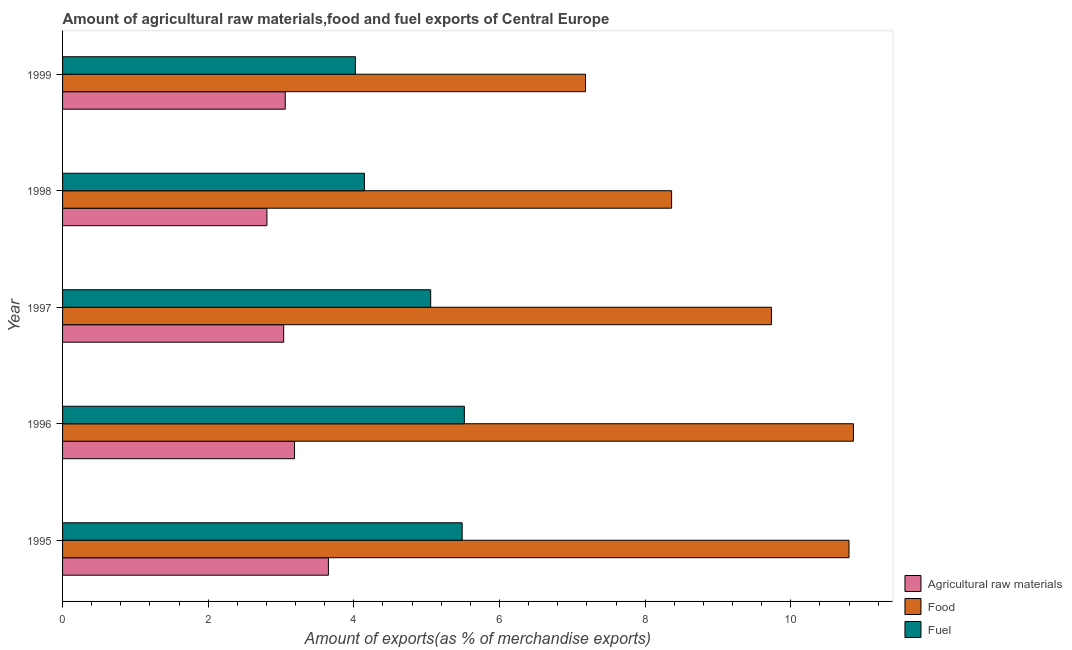How many groups of bars are there?
Your answer should be compact. 5. Are the number of bars on each tick of the Y-axis equal?
Keep it short and to the point. Yes. How many bars are there on the 2nd tick from the top?
Your answer should be very brief. 3. In how many cases, is the number of bars for a given year not equal to the number of legend labels?
Keep it short and to the point. 0. What is the percentage of raw materials exports in 1996?
Keep it short and to the point. 3.19. Across all years, what is the maximum percentage of food exports?
Ensure brevity in your answer.  10.86. Across all years, what is the minimum percentage of food exports?
Provide a succinct answer. 7.18. What is the total percentage of food exports in the graph?
Your answer should be compact. 46.94. What is the difference between the percentage of raw materials exports in 1996 and that in 1998?
Provide a short and direct response. 0.38. What is the difference between the percentage of fuel exports in 1998 and the percentage of food exports in 1996?
Provide a short and direct response. -6.71. What is the average percentage of food exports per year?
Make the answer very short. 9.39. In the year 1995, what is the difference between the percentage of fuel exports and percentage of raw materials exports?
Ensure brevity in your answer.  1.84. What is the ratio of the percentage of raw materials exports in 1998 to that in 1999?
Offer a very short reply. 0.92. What is the difference between the highest and the second highest percentage of raw materials exports?
Provide a succinct answer. 0.47. What is the difference between the highest and the lowest percentage of raw materials exports?
Ensure brevity in your answer.  0.84. In how many years, is the percentage of raw materials exports greater than the average percentage of raw materials exports taken over all years?
Keep it short and to the point. 2. Is the sum of the percentage of fuel exports in 1995 and 1996 greater than the maximum percentage of raw materials exports across all years?
Provide a succinct answer. Yes. What does the 3rd bar from the top in 1997 represents?
Your response must be concise. Agricultural raw materials. What does the 1st bar from the bottom in 1995 represents?
Provide a short and direct response. Agricultural raw materials. How many years are there in the graph?
Make the answer very short. 5. What is the difference between two consecutive major ticks on the X-axis?
Your response must be concise. 2. Does the graph contain any zero values?
Offer a terse response. No. How many legend labels are there?
Your response must be concise. 3. How are the legend labels stacked?
Give a very brief answer. Vertical. What is the title of the graph?
Your answer should be very brief. Amount of agricultural raw materials,food and fuel exports of Central Europe. Does "Wage workers" appear as one of the legend labels in the graph?
Provide a succinct answer. No. What is the label or title of the X-axis?
Ensure brevity in your answer.  Amount of exports(as % of merchandise exports). What is the label or title of the Y-axis?
Your answer should be compact. Year. What is the Amount of exports(as % of merchandise exports) of Agricultural raw materials in 1995?
Ensure brevity in your answer.  3.65. What is the Amount of exports(as % of merchandise exports) in Food in 1995?
Offer a very short reply. 10.8. What is the Amount of exports(as % of merchandise exports) in Fuel in 1995?
Give a very brief answer. 5.49. What is the Amount of exports(as % of merchandise exports) of Agricultural raw materials in 1996?
Your response must be concise. 3.19. What is the Amount of exports(as % of merchandise exports) in Food in 1996?
Your response must be concise. 10.86. What is the Amount of exports(as % of merchandise exports) in Fuel in 1996?
Provide a short and direct response. 5.52. What is the Amount of exports(as % of merchandise exports) of Agricultural raw materials in 1997?
Your response must be concise. 3.04. What is the Amount of exports(as % of merchandise exports) of Food in 1997?
Give a very brief answer. 9.73. What is the Amount of exports(as % of merchandise exports) in Fuel in 1997?
Keep it short and to the point. 5.06. What is the Amount of exports(as % of merchandise exports) of Agricultural raw materials in 1998?
Provide a short and direct response. 2.81. What is the Amount of exports(as % of merchandise exports) in Food in 1998?
Keep it short and to the point. 8.36. What is the Amount of exports(as % of merchandise exports) in Fuel in 1998?
Give a very brief answer. 4.15. What is the Amount of exports(as % of merchandise exports) of Agricultural raw materials in 1999?
Your answer should be compact. 3.06. What is the Amount of exports(as % of merchandise exports) of Food in 1999?
Keep it short and to the point. 7.18. What is the Amount of exports(as % of merchandise exports) of Fuel in 1999?
Provide a short and direct response. 4.02. Across all years, what is the maximum Amount of exports(as % of merchandise exports) of Agricultural raw materials?
Offer a terse response. 3.65. Across all years, what is the maximum Amount of exports(as % of merchandise exports) of Food?
Offer a very short reply. 10.86. Across all years, what is the maximum Amount of exports(as % of merchandise exports) in Fuel?
Provide a succinct answer. 5.52. Across all years, what is the minimum Amount of exports(as % of merchandise exports) in Agricultural raw materials?
Provide a short and direct response. 2.81. Across all years, what is the minimum Amount of exports(as % of merchandise exports) of Food?
Provide a succinct answer. 7.18. Across all years, what is the minimum Amount of exports(as % of merchandise exports) in Fuel?
Your answer should be very brief. 4.02. What is the total Amount of exports(as % of merchandise exports) in Agricultural raw materials in the graph?
Your response must be concise. 15.74. What is the total Amount of exports(as % of merchandise exports) of Food in the graph?
Make the answer very short. 46.94. What is the total Amount of exports(as % of merchandise exports) in Fuel in the graph?
Provide a short and direct response. 24.23. What is the difference between the Amount of exports(as % of merchandise exports) in Agricultural raw materials in 1995 and that in 1996?
Your response must be concise. 0.47. What is the difference between the Amount of exports(as % of merchandise exports) in Food in 1995 and that in 1996?
Offer a terse response. -0.06. What is the difference between the Amount of exports(as % of merchandise exports) of Fuel in 1995 and that in 1996?
Ensure brevity in your answer.  -0.03. What is the difference between the Amount of exports(as % of merchandise exports) of Agricultural raw materials in 1995 and that in 1997?
Your answer should be very brief. 0.61. What is the difference between the Amount of exports(as % of merchandise exports) in Food in 1995 and that in 1997?
Offer a terse response. 1.07. What is the difference between the Amount of exports(as % of merchandise exports) in Fuel in 1995 and that in 1997?
Your response must be concise. 0.43. What is the difference between the Amount of exports(as % of merchandise exports) in Agricultural raw materials in 1995 and that in 1998?
Provide a succinct answer. 0.84. What is the difference between the Amount of exports(as % of merchandise exports) in Food in 1995 and that in 1998?
Your answer should be compact. 2.44. What is the difference between the Amount of exports(as % of merchandise exports) in Fuel in 1995 and that in 1998?
Provide a succinct answer. 1.34. What is the difference between the Amount of exports(as % of merchandise exports) in Agricultural raw materials in 1995 and that in 1999?
Your response must be concise. 0.59. What is the difference between the Amount of exports(as % of merchandise exports) of Food in 1995 and that in 1999?
Offer a very short reply. 3.62. What is the difference between the Amount of exports(as % of merchandise exports) in Fuel in 1995 and that in 1999?
Your response must be concise. 1.47. What is the difference between the Amount of exports(as % of merchandise exports) in Agricultural raw materials in 1996 and that in 1997?
Keep it short and to the point. 0.15. What is the difference between the Amount of exports(as % of merchandise exports) in Food in 1996 and that in 1997?
Provide a succinct answer. 1.13. What is the difference between the Amount of exports(as % of merchandise exports) of Fuel in 1996 and that in 1997?
Your answer should be compact. 0.46. What is the difference between the Amount of exports(as % of merchandise exports) in Agricultural raw materials in 1996 and that in 1998?
Offer a terse response. 0.38. What is the difference between the Amount of exports(as % of merchandise exports) of Food in 1996 and that in 1998?
Offer a very short reply. 2.5. What is the difference between the Amount of exports(as % of merchandise exports) in Fuel in 1996 and that in 1998?
Ensure brevity in your answer.  1.37. What is the difference between the Amount of exports(as % of merchandise exports) of Agricultural raw materials in 1996 and that in 1999?
Give a very brief answer. 0.13. What is the difference between the Amount of exports(as % of merchandise exports) in Food in 1996 and that in 1999?
Keep it short and to the point. 3.68. What is the difference between the Amount of exports(as % of merchandise exports) of Fuel in 1996 and that in 1999?
Offer a very short reply. 1.5. What is the difference between the Amount of exports(as % of merchandise exports) in Agricultural raw materials in 1997 and that in 1998?
Provide a succinct answer. 0.23. What is the difference between the Amount of exports(as % of merchandise exports) in Food in 1997 and that in 1998?
Offer a terse response. 1.37. What is the difference between the Amount of exports(as % of merchandise exports) in Fuel in 1997 and that in 1998?
Your response must be concise. 0.91. What is the difference between the Amount of exports(as % of merchandise exports) of Agricultural raw materials in 1997 and that in 1999?
Ensure brevity in your answer.  -0.02. What is the difference between the Amount of exports(as % of merchandise exports) of Food in 1997 and that in 1999?
Ensure brevity in your answer.  2.55. What is the difference between the Amount of exports(as % of merchandise exports) of Fuel in 1997 and that in 1999?
Keep it short and to the point. 1.03. What is the difference between the Amount of exports(as % of merchandise exports) of Agricultural raw materials in 1998 and that in 1999?
Provide a short and direct response. -0.25. What is the difference between the Amount of exports(as % of merchandise exports) in Food in 1998 and that in 1999?
Your answer should be compact. 1.18. What is the difference between the Amount of exports(as % of merchandise exports) in Fuel in 1998 and that in 1999?
Keep it short and to the point. 0.12. What is the difference between the Amount of exports(as % of merchandise exports) in Agricultural raw materials in 1995 and the Amount of exports(as % of merchandise exports) in Food in 1996?
Offer a terse response. -7.21. What is the difference between the Amount of exports(as % of merchandise exports) of Agricultural raw materials in 1995 and the Amount of exports(as % of merchandise exports) of Fuel in 1996?
Offer a terse response. -1.87. What is the difference between the Amount of exports(as % of merchandise exports) of Food in 1995 and the Amount of exports(as % of merchandise exports) of Fuel in 1996?
Your answer should be compact. 5.28. What is the difference between the Amount of exports(as % of merchandise exports) of Agricultural raw materials in 1995 and the Amount of exports(as % of merchandise exports) of Food in 1997?
Offer a very short reply. -6.08. What is the difference between the Amount of exports(as % of merchandise exports) of Agricultural raw materials in 1995 and the Amount of exports(as % of merchandise exports) of Fuel in 1997?
Your answer should be compact. -1.4. What is the difference between the Amount of exports(as % of merchandise exports) in Food in 1995 and the Amount of exports(as % of merchandise exports) in Fuel in 1997?
Provide a short and direct response. 5.74. What is the difference between the Amount of exports(as % of merchandise exports) in Agricultural raw materials in 1995 and the Amount of exports(as % of merchandise exports) in Food in 1998?
Offer a very short reply. -4.71. What is the difference between the Amount of exports(as % of merchandise exports) in Agricultural raw materials in 1995 and the Amount of exports(as % of merchandise exports) in Fuel in 1998?
Offer a terse response. -0.49. What is the difference between the Amount of exports(as % of merchandise exports) in Food in 1995 and the Amount of exports(as % of merchandise exports) in Fuel in 1998?
Provide a short and direct response. 6.65. What is the difference between the Amount of exports(as % of merchandise exports) in Agricultural raw materials in 1995 and the Amount of exports(as % of merchandise exports) in Food in 1999?
Provide a succinct answer. -3.53. What is the difference between the Amount of exports(as % of merchandise exports) of Agricultural raw materials in 1995 and the Amount of exports(as % of merchandise exports) of Fuel in 1999?
Offer a terse response. -0.37. What is the difference between the Amount of exports(as % of merchandise exports) of Food in 1995 and the Amount of exports(as % of merchandise exports) of Fuel in 1999?
Give a very brief answer. 6.78. What is the difference between the Amount of exports(as % of merchandise exports) in Agricultural raw materials in 1996 and the Amount of exports(as % of merchandise exports) in Food in 1997?
Provide a succinct answer. -6.55. What is the difference between the Amount of exports(as % of merchandise exports) in Agricultural raw materials in 1996 and the Amount of exports(as % of merchandise exports) in Fuel in 1997?
Your response must be concise. -1.87. What is the difference between the Amount of exports(as % of merchandise exports) in Food in 1996 and the Amount of exports(as % of merchandise exports) in Fuel in 1997?
Offer a very short reply. 5.8. What is the difference between the Amount of exports(as % of merchandise exports) in Agricultural raw materials in 1996 and the Amount of exports(as % of merchandise exports) in Food in 1998?
Your answer should be compact. -5.18. What is the difference between the Amount of exports(as % of merchandise exports) of Agricultural raw materials in 1996 and the Amount of exports(as % of merchandise exports) of Fuel in 1998?
Give a very brief answer. -0.96. What is the difference between the Amount of exports(as % of merchandise exports) of Food in 1996 and the Amount of exports(as % of merchandise exports) of Fuel in 1998?
Give a very brief answer. 6.71. What is the difference between the Amount of exports(as % of merchandise exports) in Agricultural raw materials in 1996 and the Amount of exports(as % of merchandise exports) in Food in 1999?
Offer a very short reply. -4. What is the difference between the Amount of exports(as % of merchandise exports) in Agricultural raw materials in 1996 and the Amount of exports(as % of merchandise exports) in Fuel in 1999?
Give a very brief answer. -0.84. What is the difference between the Amount of exports(as % of merchandise exports) in Food in 1996 and the Amount of exports(as % of merchandise exports) in Fuel in 1999?
Offer a very short reply. 6.84. What is the difference between the Amount of exports(as % of merchandise exports) of Agricultural raw materials in 1997 and the Amount of exports(as % of merchandise exports) of Food in 1998?
Your response must be concise. -5.33. What is the difference between the Amount of exports(as % of merchandise exports) of Agricultural raw materials in 1997 and the Amount of exports(as % of merchandise exports) of Fuel in 1998?
Keep it short and to the point. -1.11. What is the difference between the Amount of exports(as % of merchandise exports) of Food in 1997 and the Amount of exports(as % of merchandise exports) of Fuel in 1998?
Provide a succinct answer. 5.59. What is the difference between the Amount of exports(as % of merchandise exports) of Agricultural raw materials in 1997 and the Amount of exports(as % of merchandise exports) of Food in 1999?
Keep it short and to the point. -4.14. What is the difference between the Amount of exports(as % of merchandise exports) of Agricultural raw materials in 1997 and the Amount of exports(as % of merchandise exports) of Fuel in 1999?
Your response must be concise. -0.98. What is the difference between the Amount of exports(as % of merchandise exports) of Food in 1997 and the Amount of exports(as % of merchandise exports) of Fuel in 1999?
Ensure brevity in your answer.  5.71. What is the difference between the Amount of exports(as % of merchandise exports) of Agricultural raw materials in 1998 and the Amount of exports(as % of merchandise exports) of Food in 1999?
Ensure brevity in your answer.  -4.37. What is the difference between the Amount of exports(as % of merchandise exports) in Agricultural raw materials in 1998 and the Amount of exports(as % of merchandise exports) in Fuel in 1999?
Your response must be concise. -1.22. What is the difference between the Amount of exports(as % of merchandise exports) in Food in 1998 and the Amount of exports(as % of merchandise exports) in Fuel in 1999?
Your answer should be compact. 4.34. What is the average Amount of exports(as % of merchandise exports) of Agricultural raw materials per year?
Keep it short and to the point. 3.15. What is the average Amount of exports(as % of merchandise exports) in Food per year?
Make the answer very short. 9.39. What is the average Amount of exports(as % of merchandise exports) of Fuel per year?
Your answer should be very brief. 4.85. In the year 1995, what is the difference between the Amount of exports(as % of merchandise exports) in Agricultural raw materials and Amount of exports(as % of merchandise exports) in Food?
Provide a short and direct response. -7.15. In the year 1995, what is the difference between the Amount of exports(as % of merchandise exports) in Agricultural raw materials and Amount of exports(as % of merchandise exports) in Fuel?
Your answer should be very brief. -1.84. In the year 1995, what is the difference between the Amount of exports(as % of merchandise exports) in Food and Amount of exports(as % of merchandise exports) in Fuel?
Provide a short and direct response. 5.31. In the year 1996, what is the difference between the Amount of exports(as % of merchandise exports) of Agricultural raw materials and Amount of exports(as % of merchandise exports) of Food?
Provide a succinct answer. -7.67. In the year 1996, what is the difference between the Amount of exports(as % of merchandise exports) in Agricultural raw materials and Amount of exports(as % of merchandise exports) in Fuel?
Provide a succinct answer. -2.33. In the year 1996, what is the difference between the Amount of exports(as % of merchandise exports) of Food and Amount of exports(as % of merchandise exports) of Fuel?
Offer a very short reply. 5.34. In the year 1997, what is the difference between the Amount of exports(as % of merchandise exports) in Agricultural raw materials and Amount of exports(as % of merchandise exports) in Food?
Keep it short and to the point. -6.7. In the year 1997, what is the difference between the Amount of exports(as % of merchandise exports) in Agricultural raw materials and Amount of exports(as % of merchandise exports) in Fuel?
Provide a succinct answer. -2.02. In the year 1997, what is the difference between the Amount of exports(as % of merchandise exports) of Food and Amount of exports(as % of merchandise exports) of Fuel?
Offer a very short reply. 4.68. In the year 1998, what is the difference between the Amount of exports(as % of merchandise exports) in Agricultural raw materials and Amount of exports(as % of merchandise exports) in Food?
Provide a succinct answer. -5.56. In the year 1998, what is the difference between the Amount of exports(as % of merchandise exports) of Agricultural raw materials and Amount of exports(as % of merchandise exports) of Fuel?
Provide a short and direct response. -1.34. In the year 1998, what is the difference between the Amount of exports(as % of merchandise exports) of Food and Amount of exports(as % of merchandise exports) of Fuel?
Offer a very short reply. 4.22. In the year 1999, what is the difference between the Amount of exports(as % of merchandise exports) in Agricultural raw materials and Amount of exports(as % of merchandise exports) in Food?
Make the answer very short. -4.12. In the year 1999, what is the difference between the Amount of exports(as % of merchandise exports) of Agricultural raw materials and Amount of exports(as % of merchandise exports) of Fuel?
Offer a very short reply. -0.96. In the year 1999, what is the difference between the Amount of exports(as % of merchandise exports) of Food and Amount of exports(as % of merchandise exports) of Fuel?
Give a very brief answer. 3.16. What is the ratio of the Amount of exports(as % of merchandise exports) in Agricultural raw materials in 1995 to that in 1996?
Make the answer very short. 1.15. What is the ratio of the Amount of exports(as % of merchandise exports) of Food in 1995 to that in 1996?
Ensure brevity in your answer.  0.99. What is the ratio of the Amount of exports(as % of merchandise exports) of Agricultural raw materials in 1995 to that in 1997?
Make the answer very short. 1.2. What is the ratio of the Amount of exports(as % of merchandise exports) of Food in 1995 to that in 1997?
Give a very brief answer. 1.11. What is the ratio of the Amount of exports(as % of merchandise exports) of Fuel in 1995 to that in 1997?
Your response must be concise. 1.09. What is the ratio of the Amount of exports(as % of merchandise exports) in Agricultural raw materials in 1995 to that in 1998?
Your answer should be compact. 1.3. What is the ratio of the Amount of exports(as % of merchandise exports) of Food in 1995 to that in 1998?
Ensure brevity in your answer.  1.29. What is the ratio of the Amount of exports(as % of merchandise exports) of Fuel in 1995 to that in 1998?
Provide a succinct answer. 1.32. What is the ratio of the Amount of exports(as % of merchandise exports) in Agricultural raw materials in 1995 to that in 1999?
Offer a terse response. 1.19. What is the ratio of the Amount of exports(as % of merchandise exports) in Food in 1995 to that in 1999?
Your response must be concise. 1.5. What is the ratio of the Amount of exports(as % of merchandise exports) of Fuel in 1995 to that in 1999?
Provide a succinct answer. 1.36. What is the ratio of the Amount of exports(as % of merchandise exports) of Agricultural raw materials in 1996 to that in 1997?
Your answer should be compact. 1.05. What is the ratio of the Amount of exports(as % of merchandise exports) of Food in 1996 to that in 1997?
Give a very brief answer. 1.12. What is the ratio of the Amount of exports(as % of merchandise exports) in Fuel in 1996 to that in 1997?
Your answer should be compact. 1.09. What is the ratio of the Amount of exports(as % of merchandise exports) of Agricultural raw materials in 1996 to that in 1998?
Make the answer very short. 1.14. What is the ratio of the Amount of exports(as % of merchandise exports) of Food in 1996 to that in 1998?
Make the answer very short. 1.3. What is the ratio of the Amount of exports(as % of merchandise exports) in Fuel in 1996 to that in 1998?
Provide a succinct answer. 1.33. What is the ratio of the Amount of exports(as % of merchandise exports) of Agricultural raw materials in 1996 to that in 1999?
Provide a short and direct response. 1.04. What is the ratio of the Amount of exports(as % of merchandise exports) in Food in 1996 to that in 1999?
Offer a very short reply. 1.51. What is the ratio of the Amount of exports(as % of merchandise exports) of Fuel in 1996 to that in 1999?
Provide a short and direct response. 1.37. What is the ratio of the Amount of exports(as % of merchandise exports) in Agricultural raw materials in 1997 to that in 1998?
Offer a very short reply. 1.08. What is the ratio of the Amount of exports(as % of merchandise exports) of Food in 1997 to that in 1998?
Provide a succinct answer. 1.16. What is the ratio of the Amount of exports(as % of merchandise exports) in Fuel in 1997 to that in 1998?
Offer a very short reply. 1.22. What is the ratio of the Amount of exports(as % of merchandise exports) of Food in 1997 to that in 1999?
Your response must be concise. 1.36. What is the ratio of the Amount of exports(as % of merchandise exports) in Fuel in 1997 to that in 1999?
Your answer should be compact. 1.26. What is the ratio of the Amount of exports(as % of merchandise exports) of Agricultural raw materials in 1998 to that in 1999?
Give a very brief answer. 0.92. What is the ratio of the Amount of exports(as % of merchandise exports) in Food in 1998 to that in 1999?
Your response must be concise. 1.16. What is the ratio of the Amount of exports(as % of merchandise exports) in Fuel in 1998 to that in 1999?
Give a very brief answer. 1.03. What is the difference between the highest and the second highest Amount of exports(as % of merchandise exports) of Agricultural raw materials?
Provide a short and direct response. 0.47. What is the difference between the highest and the second highest Amount of exports(as % of merchandise exports) of Food?
Ensure brevity in your answer.  0.06. What is the difference between the highest and the second highest Amount of exports(as % of merchandise exports) of Fuel?
Your response must be concise. 0.03. What is the difference between the highest and the lowest Amount of exports(as % of merchandise exports) in Agricultural raw materials?
Ensure brevity in your answer.  0.84. What is the difference between the highest and the lowest Amount of exports(as % of merchandise exports) of Food?
Your answer should be very brief. 3.68. What is the difference between the highest and the lowest Amount of exports(as % of merchandise exports) of Fuel?
Make the answer very short. 1.5. 